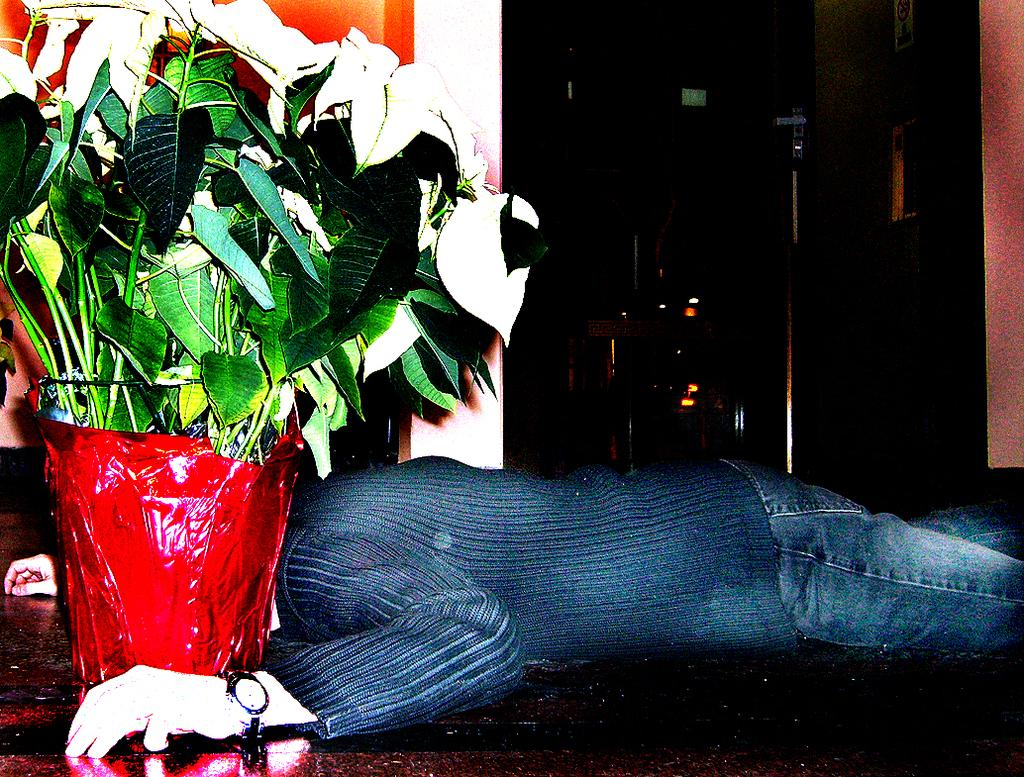Who or what is present in the image? There is a person in the image. What object can be seen on the floor? There is a houseplant on the floor. How would you describe the lighting in the image? The background of the image is dark. Where is the calendar located in the image? There is no calendar present in the image. What type of teeth can be seen in the image? There are no teeth visible in the image. 